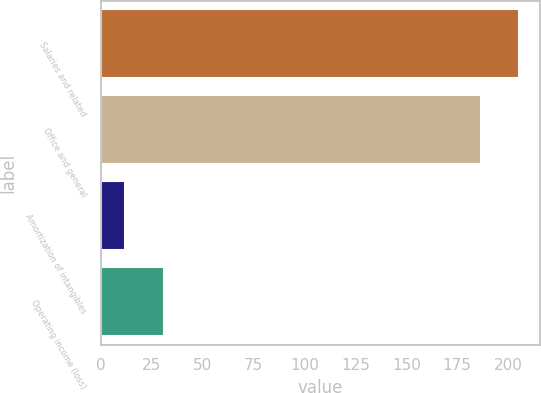Convert chart to OTSL. <chart><loc_0><loc_0><loc_500><loc_500><bar_chart><fcel>Salaries and related<fcel>Office and general<fcel>Amortization of intangibles<fcel>Operating income (loss)<nl><fcel>205.32<fcel>186.5<fcel>12.1<fcel>30.92<nl></chart> 